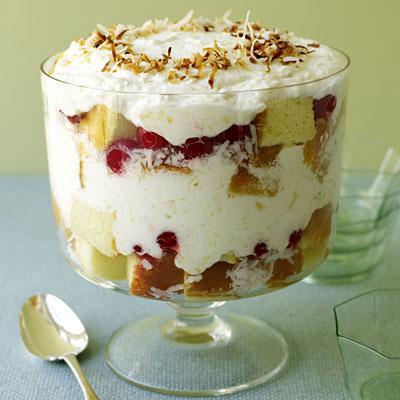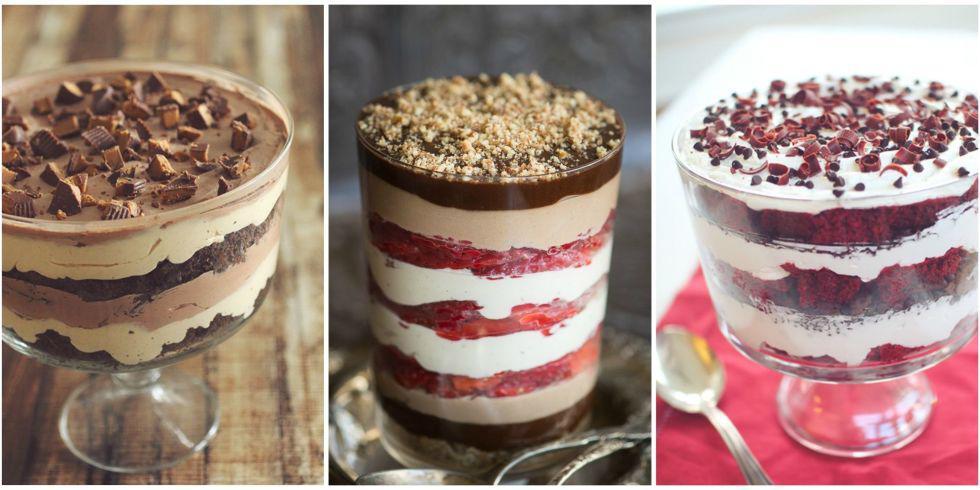The first image is the image on the left, the second image is the image on the right. Examine the images to the left and right. Is the description "A spoon is sitting on the left of the dessert bowls in at least one of the images." accurate? Answer yes or no. Yes. 